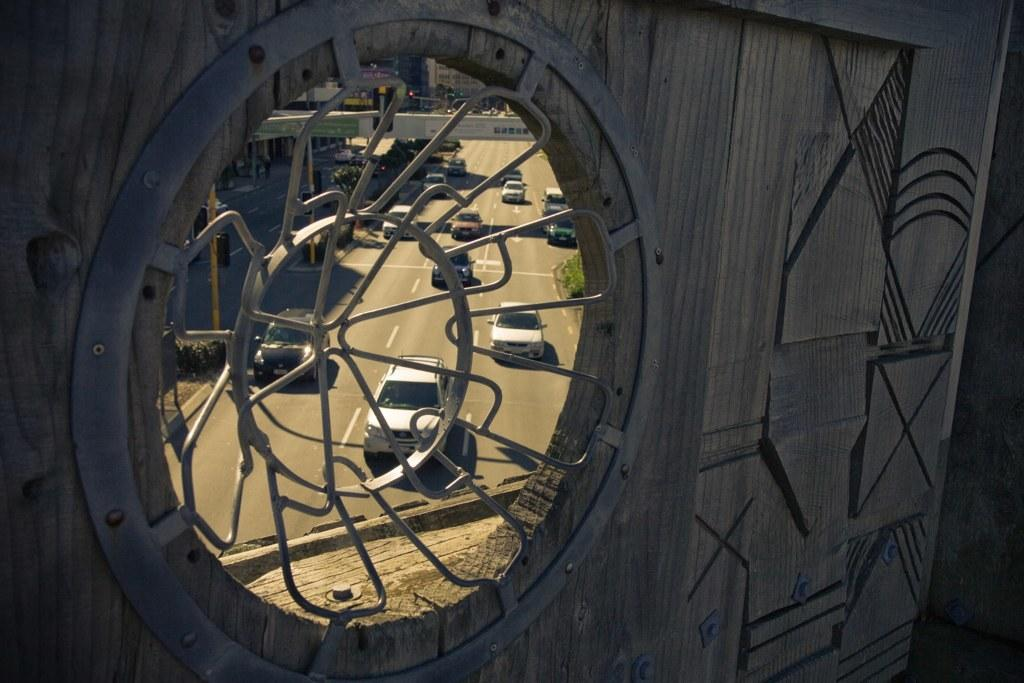What is happening on the road in the image? Cars are passing on the road in the image. Can you describe a specific feature of the image? There is a circular shaped metal window in the image. What flavor of ice cream does the metal window prefer? The metal window does not have a flavor preference, as it is an inanimate object and cannot consume ice cream. 